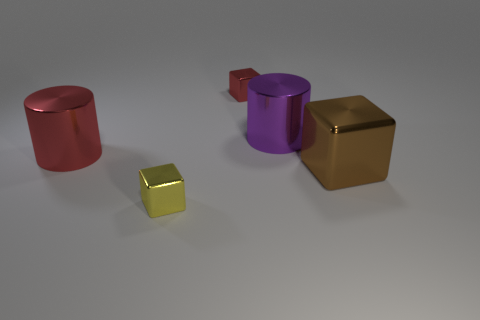What is the shape of the big metallic object right of the big shiny cylinder that is on the right side of the cylinder left of the yellow shiny thing?
Your response must be concise. Cube. Are there fewer large purple cylinders that are behind the small red shiny cube than small red metal things in front of the brown metal thing?
Keep it short and to the point. No. Is there another big metal block that has the same color as the large metallic cube?
Your response must be concise. No. Is the material of the big purple thing the same as the tiny thing that is behind the large purple metal cylinder?
Offer a terse response. Yes. There is a small metallic thing behind the large red thing; are there any metal cylinders that are behind it?
Offer a terse response. No. What is the color of the shiny cube that is left of the big purple metallic cylinder and in front of the tiny red cube?
Give a very brief answer. Yellow. What size is the purple cylinder?
Provide a short and direct response. Large. What number of yellow blocks have the same size as the brown block?
Make the answer very short. 0. Does the small block in front of the purple shiny cylinder have the same material as the cylinder to the left of the small yellow metallic block?
Keep it short and to the point. Yes. How many large purple things have the same shape as the large brown thing?
Keep it short and to the point. 0. 